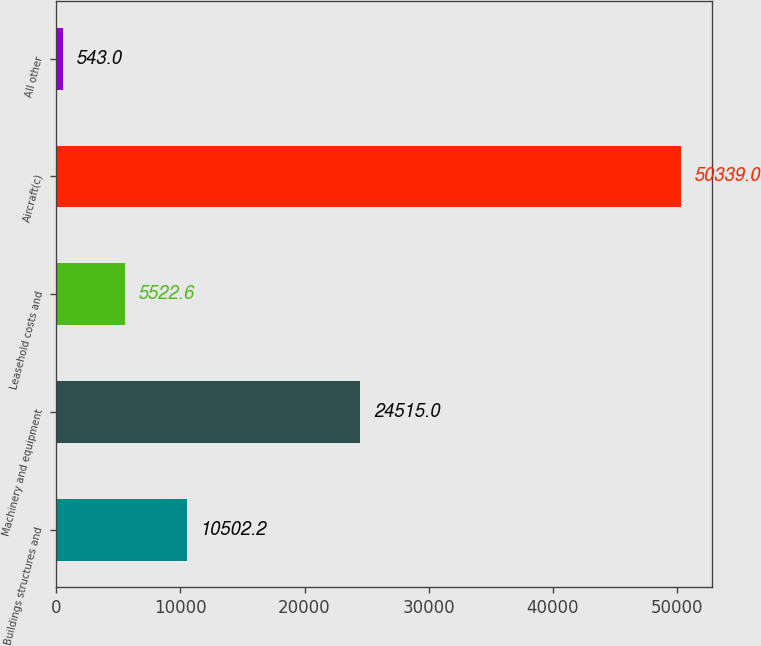<chart> <loc_0><loc_0><loc_500><loc_500><bar_chart><fcel>Buildings structures and<fcel>Machinery and equipment<fcel>Leasehold costs and<fcel>Aircraft(c)<fcel>All other<nl><fcel>10502.2<fcel>24515<fcel>5522.6<fcel>50339<fcel>543<nl></chart> 